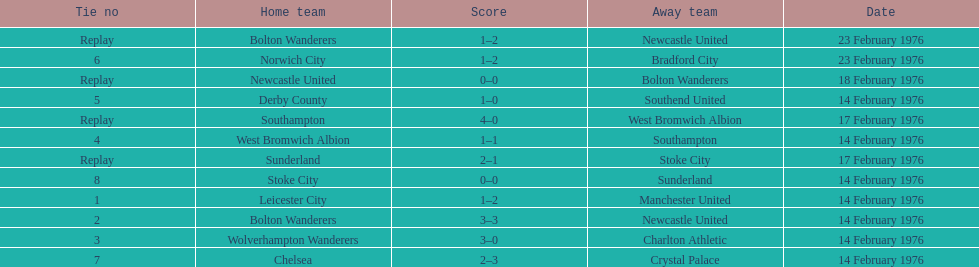What were the home teams in the 1975-76 fa cup? Leicester City, Bolton Wanderers, Newcastle United, Bolton Wanderers, Wolverhampton Wanderers, West Bromwich Albion, Southampton, Derby County, Norwich City, Chelsea, Stoke City, Sunderland. Which of these teams had the tie number 1? Leicester City. 